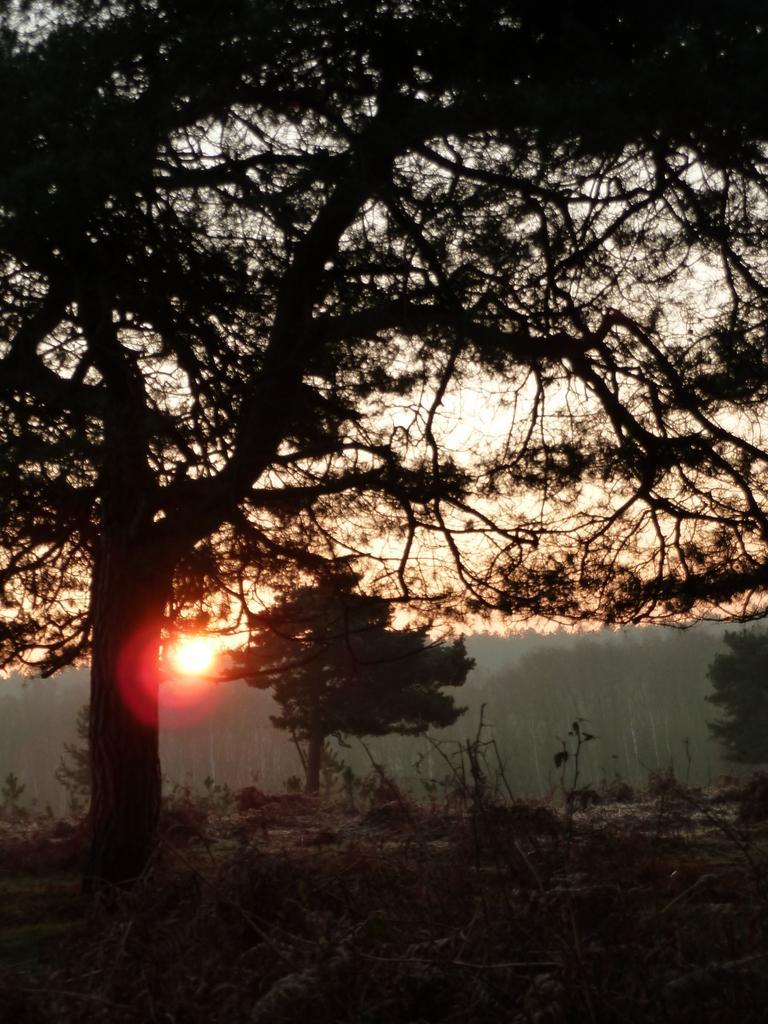What type of vegetation is present on the ground in the image? There are plants on the ground in the image. What other type of vegetation can be seen in the image? There are trees in the image. What is the source of light in the image? Sunshine is visible in the image. What type of debt is being discussed in the image? There is no mention of debt in the image; it features plants, trees, and sunshine. How is the mist affecting the plants in the image? There is no mist present in the image; it features plants, trees, and sunshine. 